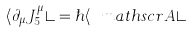Convert formula to latex. <formula><loc_0><loc_0><loc_500><loc_500>\langle \partial _ { \mu } J _ { 5 } ^ { \mu } \rangle = \hbar { \langle } { \ m a t h s c r A } \rangle</formula> 